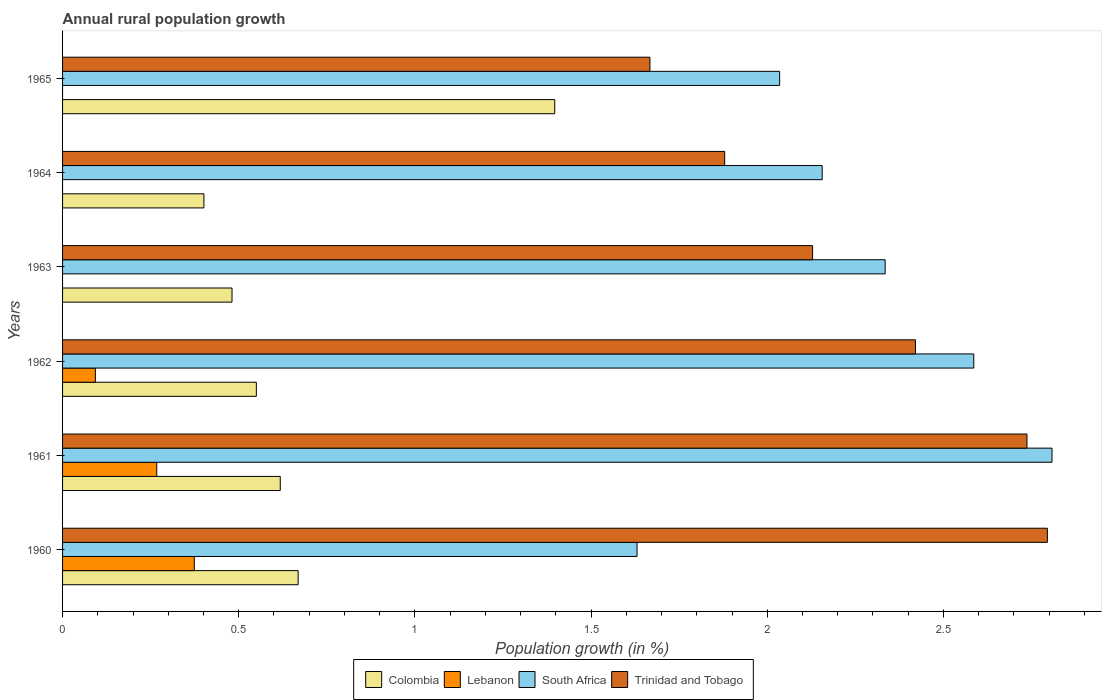How many different coloured bars are there?
Provide a short and direct response. 4. How many groups of bars are there?
Your answer should be compact. 6. Are the number of bars per tick equal to the number of legend labels?
Give a very brief answer. No. How many bars are there on the 1st tick from the top?
Make the answer very short. 3. How many bars are there on the 2nd tick from the bottom?
Keep it short and to the point. 4. What is the percentage of rural population growth in Colombia in 1965?
Make the answer very short. 1.4. Across all years, what is the maximum percentage of rural population growth in Lebanon?
Your answer should be compact. 0.37. Across all years, what is the minimum percentage of rural population growth in South Africa?
Ensure brevity in your answer.  1.63. What is the total percentage of rural population growth in South Africa in the graph?
Make the answer very short. 13.55. What is the difference between the percentage of rural population growth in Colombia in 1962 and that in 1963?
Your response must be concise. 0.07. What is the difference between the percentage of rural population growth in Colombia in 1964 and the percentage of rural population growth in Lebanon in 1960?
Your response must be concise. 0.03. What is the average percentage of rural population growth in South Africa per year?
Give a very brief answer. 2.26. In the year 1962, what is the difference between the percentage of rural population growth in South Africa and percentage of rural population growth in Lebanon?
Provide a short and direct response. 2.49. What is the ratio of the percentage of rural population growth in Trinidad and Tobago in 1961 to that in 1962?
Your answer should be compact. 1.13. Is the percentage of rural population growth in Colombia in 1961 less than that in 1964?
Your answer should be compact. No. What is the difference between the highest and the second highest percentage of rural population growth in Lebanon?
Your answer should be compact. 0.11. What is the difference between the highest and the lowest percentage of rural population growth in South Africa?
Give a very brief answer. 1.18. Is it the case that in every year, the sum of the percentage of rural population growth in Colombia and percentage of rural population growth in Lebanon is greater than the sum of percentage of rural population growth in South Africa and percentage of rural population growth in Trinidad and Tobago?
Your answer should be compact. No. Is it the case that in every year, the sum of the percentage of rural population growth in Trinidad and Tobago and percentage of rural population growth in Lebanon is greater than the percentage of rural population growth in Colombia?
Give a very brief answer. Yes. Are all the bars in the graph horizontal?
Your answer should be very brief. Yes. How many years are there in the graph?
Your response must be concise. 6. What is the difference between two consecutive major ticks on the X-axis?
Give a very brief answer. 0.5. Are the values on the major ticks of X-axis written in scientific E-notation?
Your answer should be very brief. No. Does the graph contain any zero values?
Your answer should be compact. Yes. Does the graph contain grids?
Keep it short and to the point. No. How many legend labels are there?
Ensure brevity in your answer.  4. How are the legend labels stacked?
Offer a terse response. Horizontal. What is the title of the graph?
Your answer should be compact. Annual rural population growth. What is the label or title of the X-axis?
Provide a succinct answer. Population growth (in %). What is the Population growth (in %) in Colombia in 1960?
Make the answer very short. 0.67. What is the Population growth (in %) in Lebanon in 1960?
Your answer should be compact. 0.37. What is the Population growth (in %) of South Africa in 1960?
Make the answer very short. 1.63. What is the Population growth (in %) in Trinidad and Tobago in 1960?
Give a very brief answer. 2.8. What is the Population growth (in %) in Colombia in 1961?
Provide a succinct answer. 0.62. What is the Population growth (in %) of Lebanon in 1961?
Offer a very short reply. 0.27. What is the Population growth (in %) of South Africa in 1961?
Keep it short and to the point. 2.81. What is the Population growth (in %) of Trinidad and Tobago in 1961?
Ensure brevity in your answer.  2.74. What is the Population growth (in %) of Colombia in 1962?
Offer a terse response. 0.55. What is the Population growth (in %) in Lebanon in 1962?
Give a very brief answer. 0.09. What is the Population growth (in %) of South Africa in 1962?
Give a very brief answer. 2.59. What is the Population growth (in %) of Trinidad and Tobago in 1962?
Give a very brief answer. 2.42. What is the Population growth (in %) of Colombia in 1963?
Make the answer very short. 0.48. What is the Population growth (in %) of South Africa in 1963?
Your answer should be compact. 2.33. What is the Population growth (in %) in Trinidad and Tobago in 1963?
Provide a succinct answer. 2.13. What is the Population growth (in %) of Colombia in 1964?
Your answer should be very brief. 0.4. What is the Population growth (in %) of Lebanon in 1964?
Offer a terse response. 0. What is the Population growth (in %) in South Africa in 1964?
Ensure brevity in your answer.  2.16. What is the Population growth (in %) of Trinidad and Tobago in 1964?
Give a very brief answer. 1.88. What is the Population growth (in %) of Colombia in 1965?
Ensure brevity in your answer.  1.4. What is the Population growth (in %) in Lebanon in 1965?
Provide a short and direct response. 0. What is the Population growth (in %) in South Africa in 1965?
Make the answer very short. 2.04. What is the Population growth (in %) of Trinidad and Tobago in 1965?
Offer a terse response. 1.67. Across all years, what is the maximum Population growth (in %) of Colombia?
Provide a succinct answer. 1.4. Across all years, what is the maximum Population growth (in %) in Lebanon?
Your answer should be very brief. 0.37. Across all years, what is the maximum Population growth (in %) in South Africa?
Make the answer very short. 2.81. Across all years, what is the maximum Population growth (in %) of Trinidad and Tobago?
Give a very brief answer. 2.8. Across all years, what is the minimum Population growth (in %) in Colombia?
Ensure brevity in your answer.  0.4. Across all years, what is the minimum Population growth (in %) of Lebanon?
Offer a very short reply. 0. Across all years, what is the minimum Population growth (in %) of South Africa?
Your answer should be very brief. 1.63. Across all years, what is the minimum Population growth (in %) in Trinidad and Tobago?
Your answer should be compact. 1.67. What is the total Population growth (in %) in Colombia in the graph?
Keep it short and to the point. 4.12. What is the total Population growth (in %) in Lebanon in the graph?
Give a very brief answer. 0.73. What is the total Population growth (in %) in South Africa in the graph?
Ensure brevity in your answer.  13.55. What is the total Population growth (in %) in Trinidad and Tobago in the graph?
Your answer should be compact. 13.63. What is the difference between the Population growth (in %) of Colombia in 1960 and that in 1961?
Provide a succinct answer. 0.05. What is the difference between the Population growth (in %) in Lebanon in 1960 and that in 1961?
Give a very brief answer. 0.11. What is the difference between the Population growth (in %) of South Africa in 1960 and that in 1961?
Offer a very short reply. -1.18. What is the difference between the Population growth (in %) of Trinidad and Tobago in 1960 and that in 1961?
Your response must be concise. 0.06. What is the difference between the Population growth (in %) in Colombia in 1960 and that in 1962?
Your response must be concise. 0.12. What is the difference between the Population growth (in %) of Lebanon in 1960 and that in 1962?
Offer a terse response. 0.28. What is the difference between the Population growth (in %) of South Africa in 1960 and that in 1962?
Keep it short and to the point. -0.96. What is the difference between the Population growth (in %) in Trinidad and Tobago in 1960 and that in 1962?
Your answer should be compact. 0.37. What is the difference between the Population growth (in %) of Colombia in 1960 and that in 1963?
Offer a very short reply. 0.19. What is the difference between the Population growth (in %) of South Africa in 1960 and that in 1963?
Your response must be concise. -0.7. What is the difference between the Population growth (in %) in Trinidad and Tobago in 1960 and that in 1963?
Ensure brevity in your answer.  0.67. What is the difference between the Population growth (in %) in Colombia in 1960 and that in 1964?
Your answer should be compact. 0.27. What is the difference between the Population growth (in %) in South Africa in 1960 and that in 1964?
Offer a terse response. -0.53. What is the difference between the Population growth (in %) in Trinidad and Tobago in 1960 and that in 1964?
Your response must be concise. 0.92. What is the difference between the Population growth (in %) of Colombia in 1960 and that in 1965?
Make the answer very short. -0.73. What is the difference between the Population growth (in %) of South Africa in 1960 and that in 1965?
Provide a succinct answer. -0.4. What is the difference between the Population growth (in %) in Trinidad and Tobago in 1960 and that in 1965?
Offer a terse response. 1.13. What is the difference between the Population growth (in %) in Colombia in 1961 and that in 1962?
Provide a succinct answer. 0.07. What is the difference between the Population growth (in %) of Lebanon in 1961 and that in 1962?
Keep it short and to the point. 0.17. What is the difference between the Population growth (in %) of South Africa in 1961 and that in 1962?
Keep it short and to the point. 0.22. What is the difference between the Population growth (in %) in Trinidad and Tobago in 1961 and that in 1962?
Your answer should be very brief. 0.32. What is the difference between the Population growth (in %) of Colombia in 1961 and that in 1963?
Your answer should be compact. 0.14. What is the difference between the Population growth (in %) of South Africa in 1961 and that in 1963?
Ensure brevity in your answer.  0.47. What is the difference between the Population growth (in %) in Trinidad and Tobago in 1961 and that in 1963?
Provide a succinct answer. 0.61. What is the difference between the Population growth (in %) of Colombia in 1961 and that in 1964?
Offer a very short reply. 0.22. What is the difference between the Population growth (in %) in South Africa in 1961 and that in 1964?
Offer a terse response. 0.65. What is the difference between the Population growth (in %) in Trinidad and Tobago in 1961 and that in 1964?
Offer a terse response. 0.86. What is the difference between the Population growth (in %) of Colombia in 1961 and that in 1965?
Ensure brevity in your answer.  -0.78. What is the difference between the Population growth (in %) in South Africa in 1961 and that in 1965?
Provide a short and direct response. 0.77. What is the difference between the Population growth (in %) of Trinidad and Tobago in 1961 and that in 1965?
Offer a very short reply. 1.07. What is the difference between the Population growth (in %) of Colombia in 1962 and that in 1963?
Provide a short and direct response. 0.07. What is the difference between the Population growth (in %) in South Africa in 1962 and that in 1963?
Provide a short and direct response. 0.25. What is the difference between the Population growth (in %) of Trinidad and Tobago in 1962 and that in 1963?
Offer a very short reply. 0.29. What is the difference between the Population growth (in %) of Colombia in 1962 and that in 1964?
Keep it short and to the point. 0.15. What is the difference between the Population growth (in %) of South Africa in 1962 and that in 1964?
Offer a terse response. 0.43. What is the difference between the Population growth (in %) of Trinidad and Tobago in 1962 and that in 1964?
Give a very brief answer. 0.54. What is the difference between the Population growth (in %) in Colombia in 1962 and that in 1965?
Keep it short and to the point. -0.85. What is the difference between the Population growth (in %) in South Africa in 1962 and that in 1965?
Offer a terse response. 0.55. What is the difference between the Population growth (in %) of Trinidad and Tobago in 1962 and that in 1965?
Keep it short and to the point. 0.75. What is the difference between the Population growth (in %) in Colombia in 1963 and that in 1964?
Ensure brevity in your answer.  0.08. What is the difference between the Population growth (in %) of South Africa in 1963 and that in 1964?
Provide a succinct answer. 0.18. What is the difference between the Population growth (in %) in Trinidad and Tobago in 1963 and that in 1964?
Your response must be concise. 0.25. What is the difference between the Population growth (in %) of Colombia in 1963 and that in 1965?
Provide a short and direct response. -0.92. What is the difference between the Population growth (in %) in South Africa in 1963 and that in 1965?
Your response must be concise. 0.3. What is the difference between the Population growth (in %) of Trinidad and Tobago in 1963 and that in 1965?
Your response must be concise. 0.46. What is the difference between the Population growth (in %) of Colombia in 1964 and that in 1965?
Provide a succinct answer. -1. What is the difference between the Population growth (in %) of South Africa in 1964 and that in 1965?
Make the answer very short. 0.12. What is the difference between the Population growth (in %) in Trinidad and Tobago in 1964 and that in 1965?
Your answer should be compact. 0.21. What is the difference between the Population growth (in %) of Colombia in 1960 and the Population growth (in %) of Lebanon in 1961?
Offer a terse response. 0.4. What is the difference between the Population growth (in %) of Colombia in 1960 and the Population growth (in %) of South Africa in 1961?
Ensure brevity in your answer.  -2.14. What is the difference between the Population growth (in %) in Colombia in 1960 and the Population growth (in %) in Trinidad and Tobago in 1961?
Keep it short and to the point. -2.07. What is the difference between the Population growth (in %) of Lebanon in 1960 and the Population growth (in %) of South Africa in 1961?
Provide a short and direct response. -2.43. What is the difference between the Population growth (in %) of Lebanon in 1960 and the Population growth (in %) of Trinidad and Tobago in 1961?
Your answer should be compact. -2.36. What is the difference between the Population growth (in %) in South Africa in 1960 and the Population growth (in %) in Trinidad and Tobago in 1961?
Your answer should be very brief. -1.11. What is the difference between the Population growth (in %) of Colombia in 1960 and the Population growth (in %) of Lebanon in 1962?
Offer a terse response. 0.58. What is the difference between the Population growth (in %) of Colombia in 1960 and the Population growth (in %) of South Africa in 1962?
Offer a terse response. -1.92. What is the difference between the Population growth (in %) in Colombia in 1960 and the Population growth (in %) in Trinidad and Tobago in 1962?
Provide a succinct answer. -1.75. What is the difference between the Population growth (in %) in Lebanon in 1960 and the Population growth (in %) in South Africa in 1962?
Provide a short and direct response. -2.21. What is the difference between the Population growth (in %) in Lebanon in 1960 and the Population growth (in %) in Trinidad and Tobago in 1962?
Provide a short and direct response. -2.05. What is the difference between the Population growth (in %) in South Africa in 1960 and the Population growth (in %) in Trinidad and Tobago in 1962?
Provide a succinct answer. -0.79. What is the difference between the Population growth (in %) in Colombia in 1960 and the Population growth (in %) in South Africa in 1963?
Provide a succinct answer. -1.67. What is the difference between the Population growth (in %) in Colombia in 1960 and the Population growth (in %) in Trinidad and Tobago in 1963?
Your answer should be very brief. -1.46. What is the difference between the Population growth (in %) in Lebanon in 1960 and the Population growth (in %) in South Africa in 1963?
Ensure brevity in your answer.  -1.96. What is the difference between the Population growth (in %) in Lebanon in 1960 and the Population growth (in %) in Trinidad and Tobago in 1963?
Offer a terse response. -1.75. What is the difference between the Population growth (in %) of South Africa in 1960 and the Population growth (in %) of Trinidad and Tobago in 1963?
Keep it short and to the point. -0.5. What is the difference between the Population growth (in %) in Colombia in 1960 and the Population growth (in %) in South Africa in 1964?
Make the answer very short. -1.49. What is the difference between the Population growth (in %) of Colombia in 1960 and the Population growth (in %) of Trinidad and Tobago in 1964?
Offer a very short reply. -1.21. What is the difference between the Population growth (in %) in Lebanon in 1960 and the Population growth (in %) in South Africa in 1964?
Provide a succinct answer. -1.78. What is the difference between the Population growth (in %) in Lebanon in 1960 and the Population growth (in %) in Trinidad and Tobago in 1964?
Your answer should be compact. -1.51. What is the difference between the Population growth (in %) of South Africa in 1960 and the Population growth (in %) of Trinidad and Tobago in 1964?
Offer a terse response. -0.25. What is the difference between the Population growth (in %) of Colombia in 1960 and the Population growth (in %) of South Africa in 1965?
Ensure brevity in your answer.  -1.37. What is the difference between the Population growth (in %) of Colombia in 1960 and the Population growth (in %) of Trinidad and Tobago in 1965?
Your answer should be very brief. -1. What is the difference between the Population growth (in %) of Lebanon in 1960 and the Population growth (in %) of South Africa in 1965?
Keep it short and to the point. -1.66. What is the difference between the Population growth (in %) of Lebanon in 1960 and the Population growth (in %) of Trinidad and Tobago in 1965?
Your response must be concise. -1.29. What is the difference between the Population growth (in %) in South Africa in 1960 and the Population growth (in %) in Trinidad and Tobago in 1965?
Ensure brevity in your answer.  -0.04. What is the difference between the Population growth (in %) of Colombia in 1961 and the Population growth (in %) of Lebanon in 1962?
Keep it short and to the point. 0.52. What is the difference between the Population growth (in %) in Colombia in 1961 and the Population growth (in %) in South Africa in 1962?
Your response must be concise. -1.97. What is the difference between the Population growth (in %) in Colombia in 1961 and the Population growth (in %) in Trinidad and Tobago in 1962?
Keep it short and to the point. -1.8. What is the difference between the Population growth (in %) in Lebanon in 1961 and the Population growth (in %) in South Africa in 1962?
Offer a very short reply. -2.32. What is the difference between the Population growth (in %) in Lebanon in 1961 and the Population growth (in %) in Trinidad and Tobago in 1962?
Your response must be concise. -2.15. What is the difference between the Population growth (in %) of South Africa in 1961 and the Population growth (in %) of Trinidad and Tobago in 1962?
Keep it short and to the point. 0.39. What is the difference between the Population growth (in %) in Colombia in 1961 and the Population growth (in %) in South Africa in 1963?
Your response must be concise. -1.72. What is the difference between the Population growth (in %) of Colombia in 1961 and the Population growth (in %) of Trinidad and Tobago in 1963?
Make the answer very short. -1.51. What is the difference between the Population growth (in %) of Lebanon in 1961 and the Population growth (in %) of South Africa in 1963?
Your answer should be compact. -2.07. What is the difference between the Population growth (in %) in Lebanon in 1961 and the Population growth (in %) in Trinidad and Tobago in 1963?
Give a very brief answer. -1.86. What is the difference between the Population growth (in %) of South Africa in 1961 and the Population growth (in %) of Trinidad and Tobago in 1963?
Your answer should be compact. 0.68. What is the difference between the Population growth (in %) of Colombia in 1961 and the Population growth (in %) of South Africa in 1964?
Offer a very short reply. -1.54. What is the difference between the Population growth (in %) of Colombia in 1961 and the Population growth (in %) of Trinidad and Tobago in 1964?
Provide a succinct answer. -1.26. What is the difference between the Population growth (in %) in Lebanon in 1961 and the Population growth (in %) in South Africa in 1964?
Provide a succinct answer. -1.89. What is the difference between the Population growth (in %) of Lebanon in 1961 and the Population growth (in %) of Trinidad and Tobago in 1964?
Your answer should be compact. -1.61. What is the difference between the Population growth (in %) in South Africa in 1961 and the Population growth (in %) in Trinidad and Tobago in 1964?
Provide a short and direct response. 0.93. What is the difference between the Population growth (in %) in Colombia in 1961 and the Population growth (in %) in South Africa in 1965?
Your response must be concise. -1.42. What is the difference between the Population growth (in %) in Colombia in 1961 and the Population growth (in %) in Trinidad and Tobago in 1965?
Your answer should be compact. -1.05. What is the difference between the Population growth (in %) in Lebanon in 1961 and the Population growth (in %) in South Africa in 1965?
Your answer should be very brief. -1.77. What is the difference between the Population growth (in %) in Lebanon in 1961 and the Population growth (in %) in Trinidad and Tobago in 1965?
Offer a very short reply. -1.4. What is the difference between the Population growth (in %) of South Africa in 1961 and the Population growth (in %) of Trinidad and Tobago in 1965?
Ensure brevity in your answer.  1.14. What is the difference between the Population growth (in %) of Colombia in 1962 and the Population growth (in %) of South Africa in 1963?
Make the answer very short. -1.78. What is the difference between the Population growth (in %) of Colombia in 1962 and the Population growth (in %) of Trinidad and Tobago in 1963?
Ensure brevity in your answer.  -1.58. What is the difference between the Population growth (in %) in Lebanon in 1962 and the Population growth (in %) in South Africa in 1963?
Ensure brevity in your answer.  -2.24. What is the difference between the Population growth (in %) of Lebanon in 1962 and the Population growth (in %) of Trinidad and Tobago in 1963?
Your answer should be compact. -2.04. What is the difference between the Population growth (in %) in South Africa in 1962 and the Population growth (in %) in Trinidad and Tobago in 1963?
Make the answer very short. 0.46. What is the difference between the Population growth (in %) of Colombia in 1962 and the Population growth (in %) of South Africa in 1964?
Make the answer very short. -1.61. What is the difference between the Population growth (in %) in Colombia in 1962 and the Population growth (in %) in Trinidad and Tobago in 1964?
Make the answer very short. -1.33. What is the difference between the Population growth (in %) of Lebanon in 1962 and the Population growth (in %) of South Africa in 1964?
Offer a very short reply. -2.06. What is the difference between the Population growth (in %) of Lebanon in 1962 and the Population growth (in %) of Trinidad and Tobago in 1964?
Provide a succinct answer. -1.79. What is the difference between the Population growth (in %) of South Africa in 1962 and the Population growth (in %) of Trinidad and Tobago in 1964?
Offer a very short reply. 0.71. What is the difference between the Population growth (in %) of Colombia in 1962 and the Population growth (in %) of South Africa in 1965?
Offer a terse response. -1.49. What is the difference between the Population growth (in %) of Colombia in 1962 and the Population growth (in %) of Trinidad and Tobago in 1965?
Provide a succinct answer. -1.12. What is the difference between the Population growth (in %) of Lebanon in 1962 and the Population growth (in %) of South Africa in 1965?
Provide a short and direct response. -1.94. What is the difference between the Population growth (in %) in Lebanon in 1962 and the Population growth (in %) in Trinidad and Tobago in 1965?
Offer a terse response. -1.57. What is the difference between the Population growth (in %) of South Africa in 1962 and the Population growth (in %) of Trinidad and Tobago in 1965?
Keep it short and to the point. 0.92. What is the difference between the Population growth (in %) of Colombia in 1963 and the Population growth (in %) of South Africa in 1964?
Make the answer very short. -1.68. What is the difference between the Population growth (in %) in Colombia in 1963 and the Population growth (in %) in Trinidad and Tobago in 1964?
Give a very brief answer. -1.4. What is the difference between the Population growth (in %) in South Africa in 1963 and the Population growth (in %) in Trinidad and Tobago in 1964?
Your answer should be very brief. 0.46. What is the difference between the Population growth (in %) in Colombia in 1963 and the Population growth (in %) in South Africa in 1965?
Keep it short and to the point. -1.55. What is the difference between the Population growth (in %) of Colombia in 1963 and the Population growth (in %) of Trinidad and Tobago in 1965?
Give a very brief answer. -1.19. What is the difference between the Population growth (in %) of South Africa in 1963 and the Population growth (in %) of Trinidad and Tobago in 1965?
Provide a short and direct response. 0.67. What is the difference between the Population growth (in %) of Colombia in 1964 and the Population growth (in %) of South Africa in 1965?
Keep it short and to the point. -1.63. What is the difference between the Population growth (in %) of Colombia in 1964 and the Population growth (in %) of Trinidad and Tobago in 1965?
Your answer should be very brief. -1.27. What is the difference between the Population growth (in %) of South Africa in 1964 and the Population growth (in %) of Trinidad and Tobago in 1965?
Offer a very short reply. 0.49. What is the average Population growth (in %) of Colombia per year?
Offer a terse response. 0.69. What is the average Population growth (in %) in Lebanon per year?
Offer a terse response. 0.12. What is the average Population growth (in %) in South Africa per year?
Offer a terse response. 2.26. What is the average Population growth (in %) of Trinidad and Tobago per year?
Keep it short and to the point. 2.27. In the year 1960, what is the difference between the Population growth (in %) of Colombia and Population growth (in %) of Lebanon?
Make the answer very short. 0.29. In the year 1960, what is the difference between the Population growth (in %) in Colombia and Population growth (in %) in South Africa?
Your answer should be compact. -0.96. In the year 1960, what is the difference between the Population growth (in %) in Colombia and Population growth (in %) in Trinidad and Tobago?
Ensure brevity in your answer.  -2.13. In the year 1960, what is the difference between the Population growth (in %) of Lebanon and Population growth (in %) of South Africa?
Ensure brevity in your answer.  -1.26. In the year 1960, what is the difference between the Population growth (in %) of Lebanon and Population growth (in %) of Trinidad and Tobago?
Provide a short and direct response. -2.42. In the year 1960, what is the difference between the Population growth (in %) in South Africa and Population growth (in %) in Trinidad and Tobago?
Your answer should be very brief. -1.16. In the year 1961, what is the difference between the Population growth (in %) of Colombia and Population growth (in %) of Lebanon?
Give a very brief answer. 0.35. In the year 1961, what is the difference between the Population growth (in %) in Colombia and Population growth (in %) in South Africa?
Give a very brief answer. -2.19. In the year 1961, what is the difference between the Population growth (in %) in Colombia and Population growth (in %) in Trinidad and Tobago?
Your answer should be compact. -2.12. In the year 1961, what is the difference between the Population growth (in %) in Lebanon and Population growth (in %) in South Africa?
Provide a short and direct response. -2.54. In the year 1961, what is the difference between the Population growth (in %) in Lebanon and Population growth (in %) in Trinidad and Tobago?
Your answer should be very brief. -2.47. In the year 1961, what is the difference between the Population growth (in %) of South Africa and Population growth (in %) of Trinidad and Tobago?
Give a very brief answer. 0.07. In the year 1962, what is the difference between the Population growth (in %) in Colombia and Population growth (in %) in Lebanon?
Offer a terse response. 0.46. In the year 1962, what is the difference between the Population growth (in %) of Colombia and Population growth (in %) of South Africa?
Your answer should be compact. -2.04. In the year 1962, what is the difference between the Population growth (in %) in Colombia and Population growth (in %) in Trinidad and Tobago?
Offer a terse response. -1.87. In the year 1962, what is the difference between the Population growth (in %) of Lebanon and Population growth (in %) of South Africa?
Your answer should be compact. -2.49. In the year 1962, what is the difference between the Population growth (in %) in Lebanon and Population growth (in %) in Trinidad and Tobago?
Offer a terse response. -2.33. In the year 1962, what is the difference between the Population growth (in %) of South Africa and Population growth (in %) of Trinidad and Tobago?
Provide a succinct answer. 0.17. In the year 1963, what is the difference between the Population growth (in %) in Colombia and Population growth (in %) in South Africa?
Your answer should be very brief. -1.85. In the year 1963, what is the difference between the Population growth (in %) in Colombia and Population growth (in %) in Trinidad and Tobago?
Keep it short and to the point. -1.65. In the year 1963, what is the difference between the Population growth (in %) in South Africa and Population growth (in %) in Trinidad and Tobago?
Your answer should be very brief. 0.21. In the year 1964, what is the difference between the Population growth (in %) in Colombia and Population growth (in %) in South Africa?
Offer a terse response. -1.75. In the year 1964, what is the difference between the Population growth (in %) of Colombia and Population growth (in %) of Trinidad and Tobago?
Give a very brief answer. -1.48. In the year 1964, what is the difference between the Population growth (in %) in South Africa and Population growth (in %) in Trinidad and Tobago?
Provide a short and direct response. 0.28. In the year 1965, what is the difference between the Population growth (in %) of Colombia and Population growth (in %) of South Africa?
Keep it short and to the point. -0.64. In the year 1965, what is the difference between the Population growth (in %) in Colombia and Population growth (in %) in Trinidad and Tobago?
Provide a succinct answer. -0.27. In the year 1965, what is the difference between the Population growth (in %) in South Africa and Population growth (in %) in Trinidad and Tobago?
Provide a succinct answer. 0.37. What is the ratio of the Population growth (in %) in Colombia in 1960 to that in 1961?
Make the answer very short. 1.08. What is the ratio of the Population growth (in %) of Lebanon in 1960 to that in 1961?
Your response must be concise. 1.4. What is the ratio of the Population growth (in %) of South Africa in 1960 to that in 1961?
Provide a succinct answer. 0.58. What is the ratio of the Population growth (in %) of Trinidad and Tobago in 1960 to that in 1961?
Ensure brevity in your answer.  1.02. What is the ratio of the Population growth (in %) in Colombia in 1960 to that in 1962?
Your response must be concise. 1.22. What is the ratio of the Population growth (in %) in Lebanon in 1960 to that in 1962?
Keep it short and to the point. 4.01. What is the ratio of the Population growth (in %) of South Africa in 1960 to that in 1962?
Keep it short and to the point. 0.63. What is the ratio of the Population growth (in %) in Trinidad and Tobago in 1960 to that in 1962?
Provide a succinct answer. 1.15. What is the ratio of the Population growth (in %) of Colombia in 1960 to that in 1963?
Your answer should be compact. 1.39. What is the ratio of the Population growth (in %) in South Africa in 1960 to that in 1963?
Offer a very short reply. 0.7. What is the ratio of the Population growth (in %) in Trinidad and Tobago in 1960 to that in 1963?
Keep it short and to the point. 1.31. What is the ratio of the Population growth (in %) of Colombia in 1960 to that in 1964?
Make the answer very short. 1.67. What is the ratio of the Population growth (in %) in South Africa in 1960 to that in 1964?
Your response must be concise. 0.76. What is the ratio of the Population growth (in %) in Trinidad and Tobago in 1960 to that in 1964?
Offer a terse response. 1.49. What is the ratio of the Population growth (in %) of Colombia in 1960 to that in 1965?
Provide a succinct answer. 0.48. What is the ratio of the Population growth (in %) in South Africa in 1960 to that in 1965?
Make the answer very short. 0.8. What is the ratio of the Population growth (in %) in Trinidad and Tobago in 1960 to that in 1965?
Offer a very short reply. 1.68. What is the ratio of the Population growth (in %) of Colombia in 1961 to that in 1962?
Your answer should be very brief. 1.12. What is the ratio of the Population growth (in %) in Lebanon in 1961 to that in 1962?
Offer a very short reply. 2.87. What is the ratio of the Population growth (in %) in South Africa in 1961 to that in 1962?
Keep it short and to the point. 1.09. What is the ratio of the Population growth (in %) in Trinidad and Tobago in 1961 to that in 1962?
Provide a short and direct response. 1.13. What is the ratio of the Population growth (in %) of Colombia in 1961 to that in 1963?
Keep it short and to the point. 1.28. What is the ratio of the Population growth (in %) in South Africa in 1961 to that in 1963?
Ensure brevity in your answer.  1.2. What is the ratio of the Population growth (in %) in Trinidad and Tobago in 1961 to that in 1963?
Provide a succinct answer. 1.29. What is the ratio of the Population growth (in %) of Colombia in 1961 to that in 1964?
Provide a short and direct response. 1.54. What is the ratio of the Population growth (in %) of South Africa in 1961 to that in 1964?
Your response must be concise. 1.3. What is the ratio of the Population growth (in %) in Trinidad and Tobago in 1961 to that in 1964?
Provide a succinct answer. 1.46. What is the ratio of the Population growth (in %) of Colombia in 1961 to that in 1965?
Offer a terse response. 0.44. What is the ratio of the Population growth (in %) of South Africa in 1961 to that in 1965?
Offer a terse response. 1.38. What is the ratio of the Population growth (in %) in Trinidad and Tobago in 1961 to that in 1965?
Your response must be concise. 1.64. What is the ratio of the Population growth (in %) in Colombia in 1962 to that in 1963?
Provide a succinct answer. 1.14. What is the ratio of the Population growth (in %) in South Africa in 1962 to that in 1963?
Ensure brevity in your answer.  1.11. What is the ratio of the Population growth (in %) in Trinidad and Tobago in 1962 to that in 1963?
Your response must be concise. 1.14. What is the ratio of the Population growth (in %) in Colombia in 1962 to that in 1964?
Keep it short and to the point. 1.37. What is the ratio of the Population growth (in %) of South Africa in 1962 to that in 1964?
Your answer should be compact. 1.2. What is the ratio of the Population growth (in %) of Trinidad and Tobago in 1962 to that in 1964?
Your answer should be very brief. 1.29. What is the ratio of the Population growth (in %) of Colombia in 1962 to that in 1965?
Provide a short and direct response. 0.39. What is the ratio of the Population growth (in %) of South Africa in 1962 to that in 1965?
Provide a short and direct response. 1.27. What is the ratio of the Population growth (in %) in Trinidad and Tobago in 1962 to that in 1965?
Give a very brief answer. 1.45. What is the ratio of the Population growth (in %) of Colombia in 1963 to that in 1964?
Offer a terse response. 1.2. What is the ratio of the Population growth (in %) in South Africa in 1963 to that in 1964?
Offer a terse response. 1.08. What is the ratio of the Population growth (in %) in Trinidad and Tobago in 1963 to that in 1964?
Offer a terse response. 1.13. What is the ratio of the Population growth (in %) in Colombia in 1963 to that in 1965?
Give a very brief answer. 0.34. What is the ratio of the Population growth (in %) in South Africa in 1963 to that in 1965?
Your response must be concise. 1.15. What is the ratio of the Population growth (in %) in Trinidad and Tobago in 1963 to that in 1965?
Make the answer very short. 1.28. What is the ratio of the Population growth (in %) in Colombia in 1964 to that in 1965?
Ensure brevity in your answer.  0.29. What is the ratio of the Population growth (in %) in South Africa in 1964 to that in 1965?
Provide a succinct answer. 1.06. What is the ratio of the Population growth (in %) in Trinidad and Tobago in 1964 to that in 1965?
Ensure brevity in your answer.  1.13. What is the difference between the highest and the second highest Population growth (in %) in Colombia?
Keep it short and to the point. 0.73. What is the difference between the highest and the second highest Population growth (in %) in Lebanon?
Ensure brevity in your answer.  0.11. What is the difference between the highest and the second highest Population growth (in %) of South Africa?
Your answer should be compact. 0.22. What is the difference between the highest and the second highest Population growth (in %) in Trinidad and Tobago?
Provide a short and direct response. 0.06. What is the difference between the highest and the lowest Population growth (in %) of Colombia?
Make the answer very short. 1. What is the difference between the highest and the lowest Population growth (in %) in Lebanon?
Offer a very short reply. 0.37. What is the difference between the highest and the lowest Population growth (in %) in South Africa?
Your answer should be very brief. 1.18. What is the difference between the highest and the lowest Population growth (in %) in Trinidad and Tobago?
Your answer should be very brief. 1.13. 